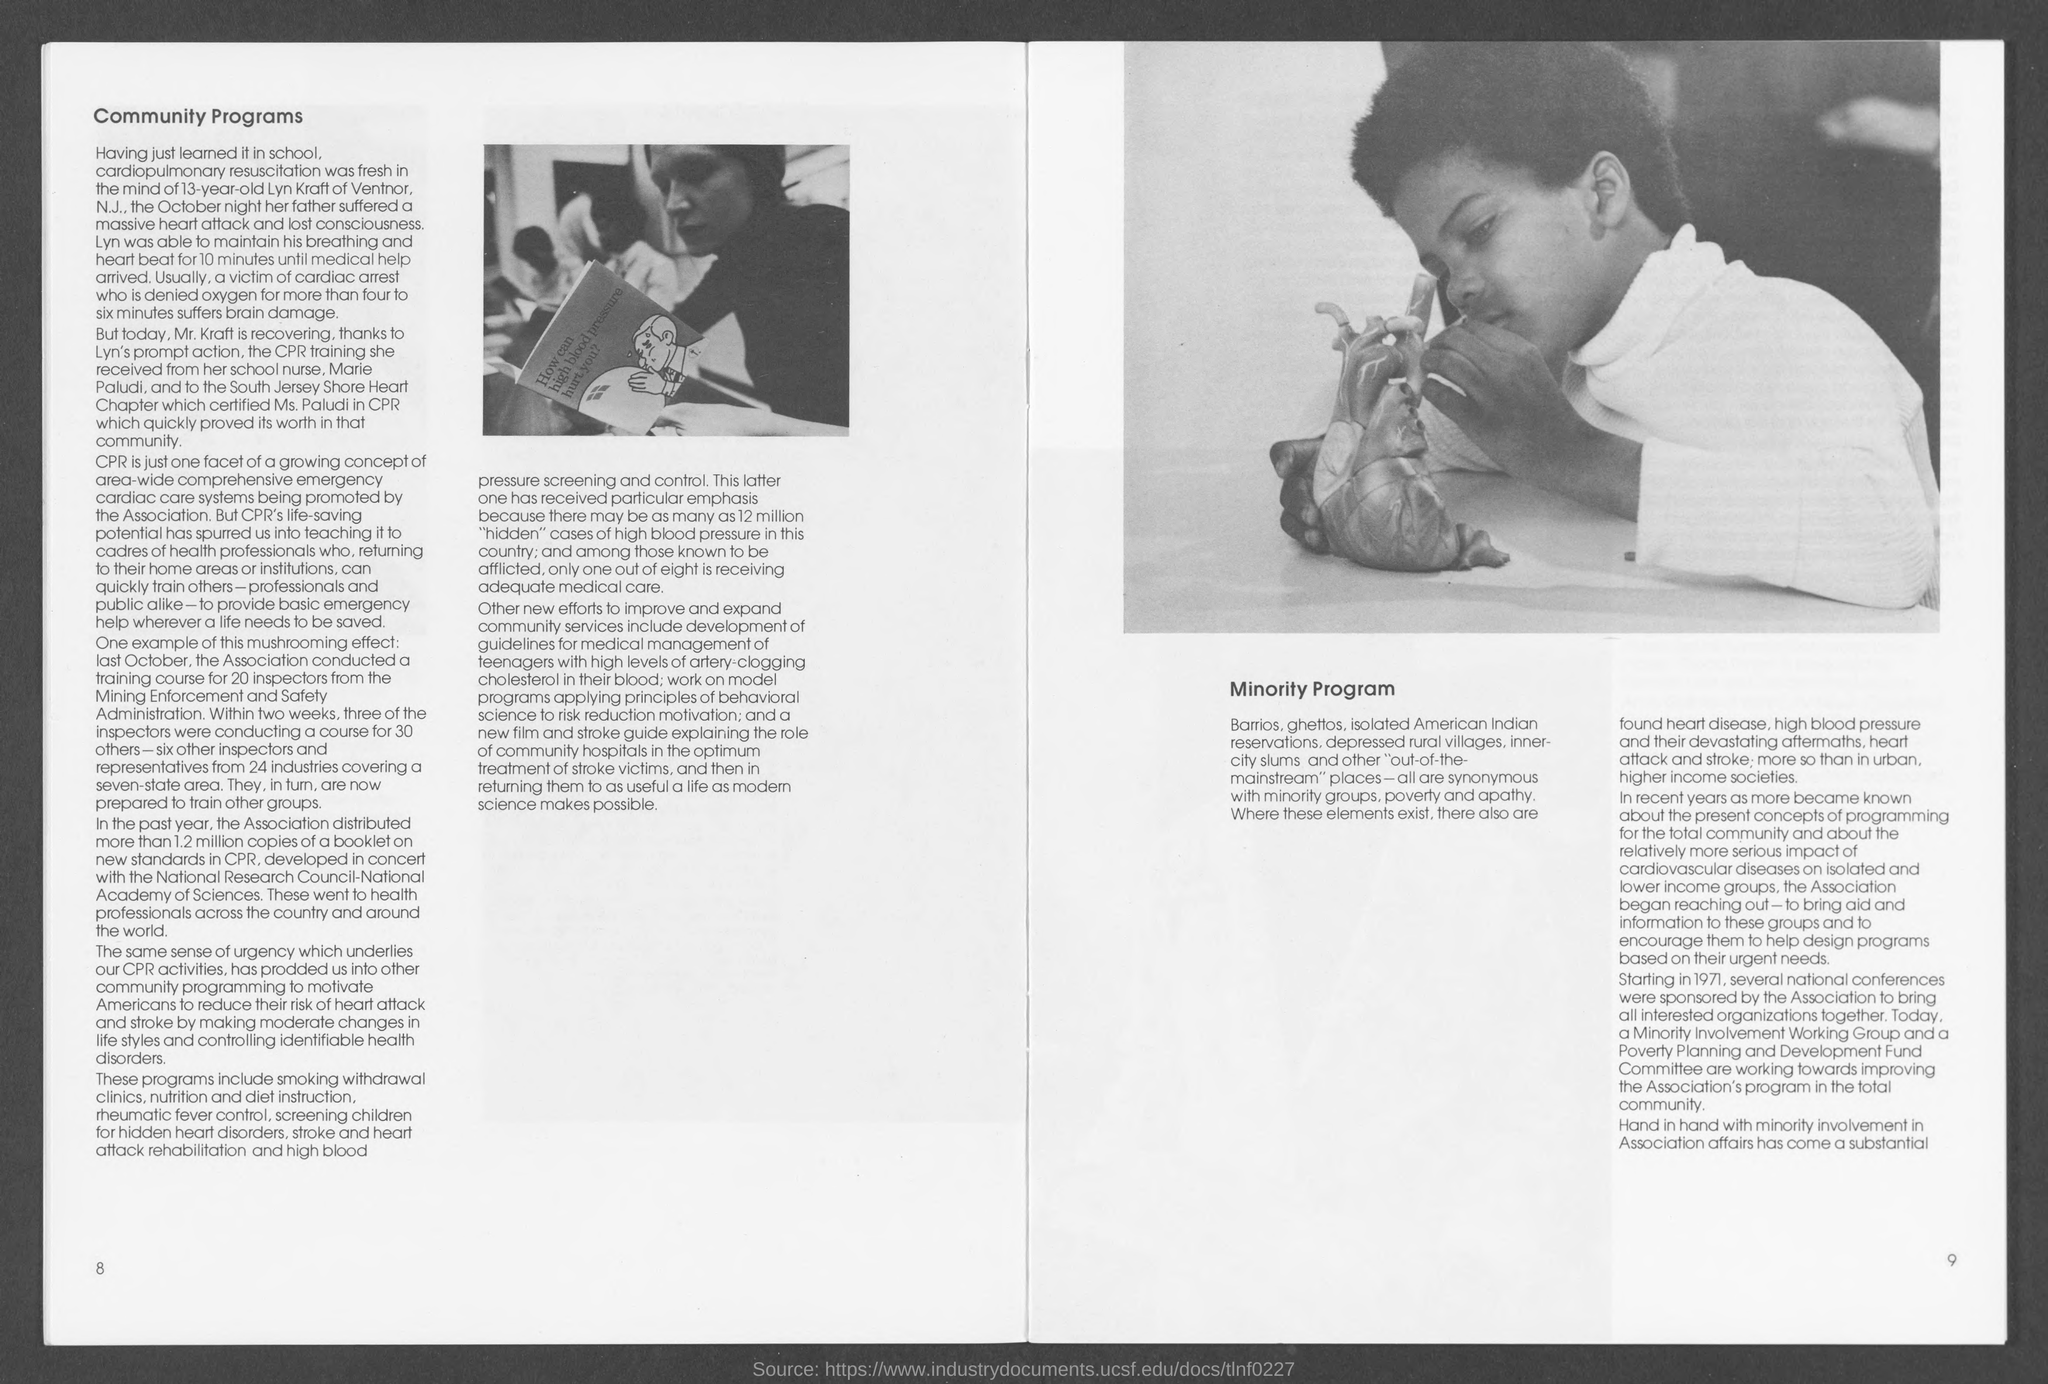Draw attention to some important aspects in this diagram. The number at the bottom right page is 9. The number at the bottom left page is 8. The heading at the top of the left page is 'Community Programs.' 